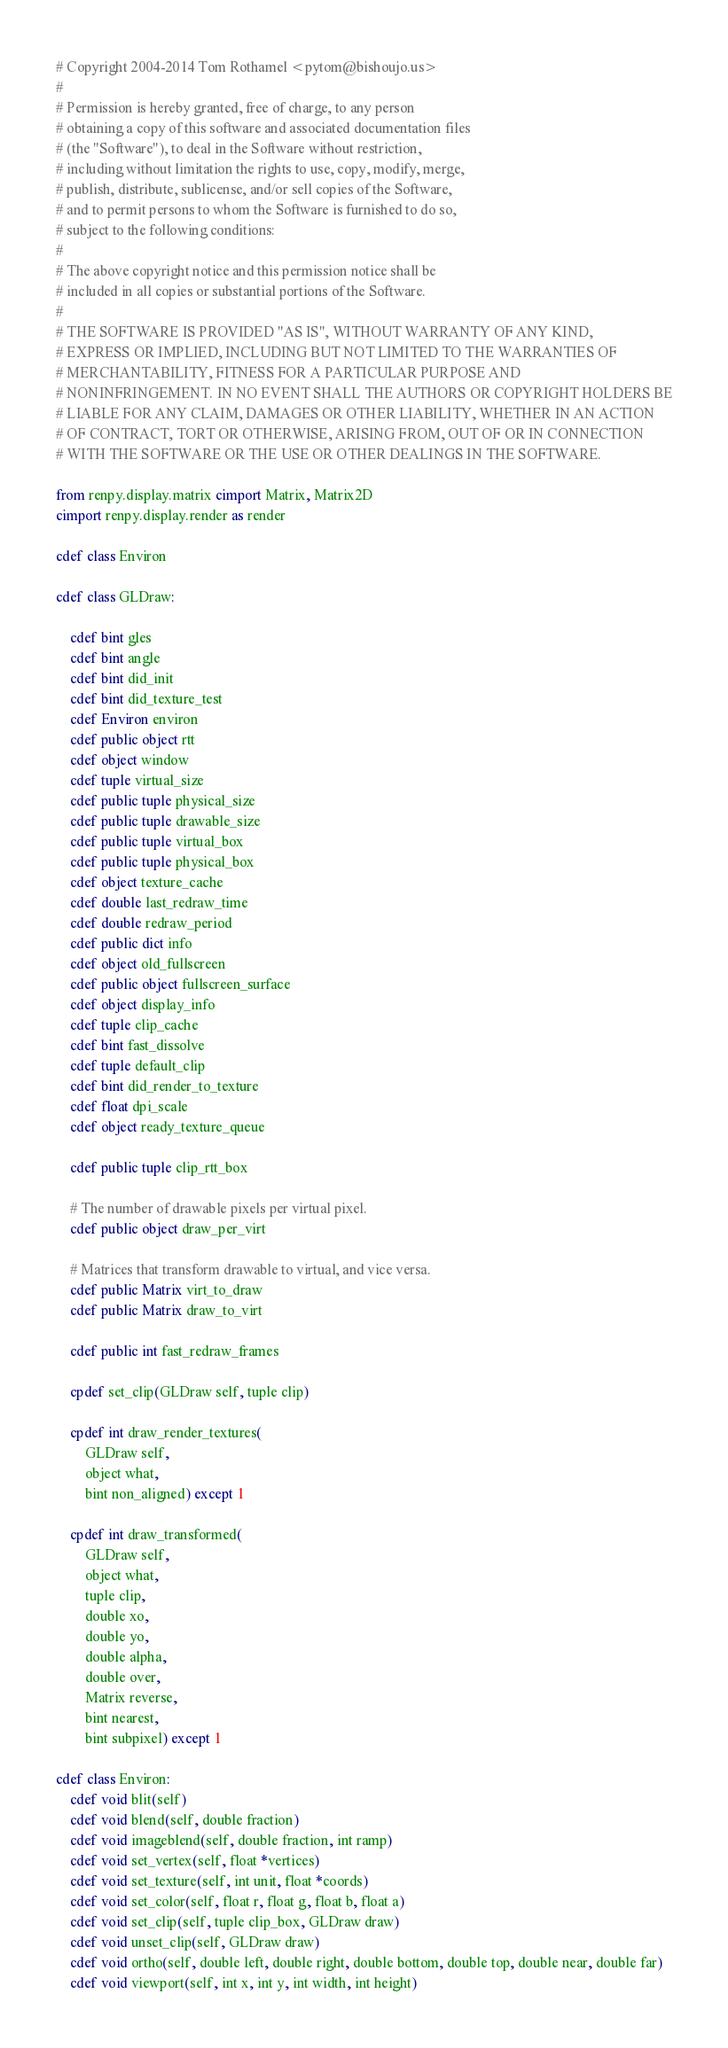Convert code to text. <code><loc_0><loc_0><loc_500><loc_500><_Cython_># Copyright 2004-2014 Tom Rothamel <pytom@bishoujo.us>
#
# Permission is hereby granted, free of charge, to any person
# obtaining a copy of this software and associated documentation files
# (the "Software"), to deal in the Software without restriction,
# including without limitation the rights to use, copy, modify, merge,
# publish, distribute, sublicense, and/or sell copies of the Software,
# and to permit persons to whom the Software is furnished to do so,
# subject to the following conditions:
#
# The above copyright notice and this permission notice shall be
# included in all copies or substantial portions of the Software.
#
# THE SOFTWARE IS PROVIDED "AS IS", WITHOUT WARRANTY OF ANY KIND,
# EXPRESS OR IMPLIED, INCLUDING BUT NOT LIMITED TO THE WARRANTIES OF
# MERCHANTABILITY, FITNESS FOR A PARTICULAR PURPOSE AND
# NONINFRINGEMENT. IN NO EVENT SHALL THE AUTHORS OR COPYRIGHT HOLDERS BE
# LIABLE FOR ANY CLAIM, DAMAGES OR OTHER LIABILITY, WHETHER IN AN ACTION
# OF CONTRACT, TORT OR OTHERWISE, ARISING FROM, OUT OF OR IN CONNECTION
# WITH THE SOFTWARE OR THE USE OR OTHER DEALINGS IN THE SOFTWARE.

from renpy.display.matrix cimport Matrix, Matrix2D
cimport renpy.display.render as render

cdef class Environ

cdef class GLDraw:

    cdef bint gles
    cdef bint angle
    cdef bint did_init
    cdef bint did_texture_test
    cdef Environ environ
    cdef public object rtt
    cdef object window
    cdef tuple virtual_size
    cdef public tuple physical_size
    cdef public tuple drawable_size
    cdef public tuple virtual_box
    cdef public tuple physical_box
    cdef object texture_cache
    cdef double last_redraw_time
    cdef double redraw_period
    cdef public dict info
    cdef object old_fullscreen
    cdef public object fullscreen_surface
    cdef object display_info
    cdef tuple clip_cache
    cdef bint fast_dissolve
    cdef tuple default_clip
    cdef bint did_render_to_texture
    cdef float dpi_scale
    cdef object ready_texture_queue

    cdef public tuple clip_rtt_box

    # The number of drawable pixels per virtual pixel.
    cdef public object draw_per_virt

    # Matrices that transform drawable to virtual, and vice versa.
    cdef public Matrix virt_to_draw
    cdef public Matrix draw_to_virt

    cdef public int fast_redraw_frames

    cpdef set_clip(GLDraw self, tuple clip)

    cpdef int draw_render_textures(
        GLDraw self,
        object what,
        bint non_aligned) except 1

    cpdef int draw_transformed(
        GLDraw self,
        object what,
        tuple clip,
        double xo,
        double yo,
        double alpha,
        double over,
        Matrix reverse,
        bint nearest,
        bint subpixel) except 1

cdef class Environ:
    cdef void blit(self)
    cdef void blend(self, double fraction)
    cdef void imageblend(self, double fraction, int ramp)
    cdef void set_vertex(self, float *vertices)
    cdef void set_texture(self, int unit, float *coords)
    cdef void set_color(self, float r, float g, float b, float a)
    cdef void set_clip(self, tuple clip_box, GLDraw draw)
    cdef void unset_clip(self, GLDraw draw)
    cdef void ortho(self, double left, double right, double bottom, double top, double near, double far)
    cdef void viewport(self, int x, int y, int width, int height)

</code> 